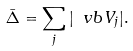Convert formula to latex. <formula><loc_0><loc_0><loc_500><loc_500>\bar { \Delta } = \sum _ { j } | \ v b V _ { j } | .</formula> 